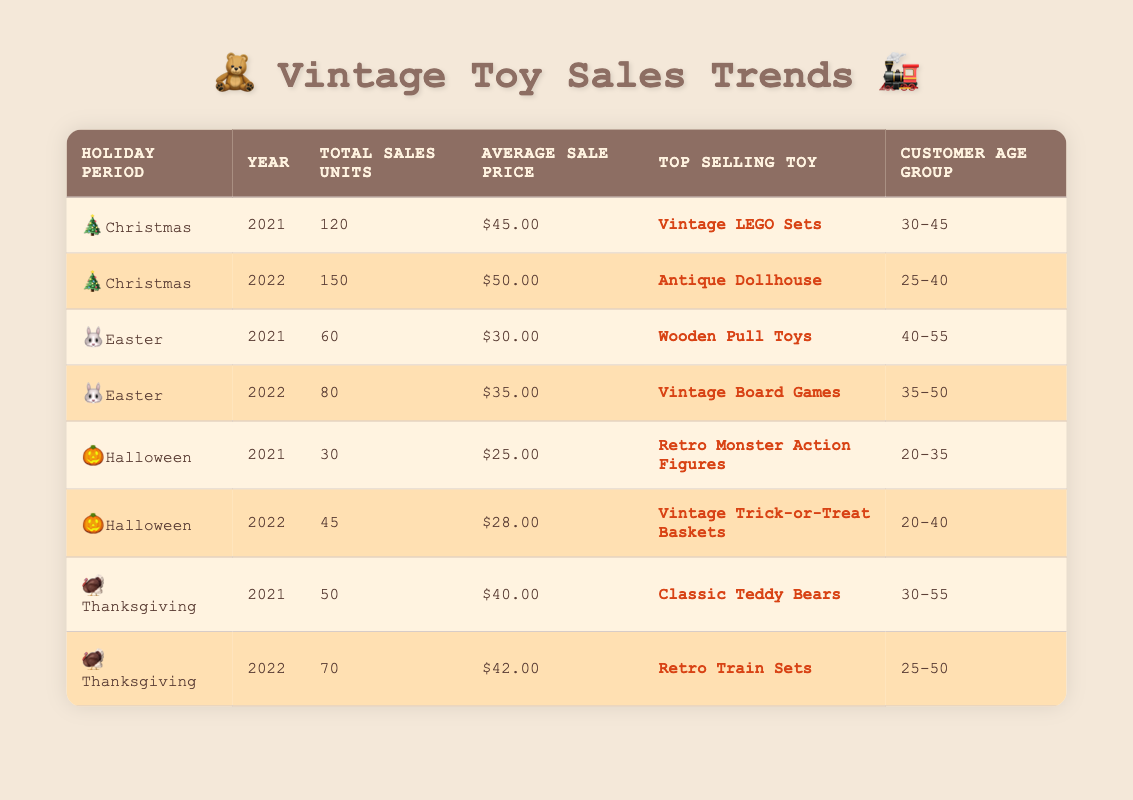What was the total sales units for Christmas in 2022? The table shows that for the holiday period of Christmas in 2022, the total sales units are listed as 150.
Answer: 150 What is the average sale price of toys during Easter in 2021? Referring to the table, the average sale price for Easter in 2021 is shown as $30.00.
Answer: $30.00 Which age group purchased the most toys during Halloween in 2022? The table indicates that for Halloween in 2022, the customer age group is listed as 20-40.
Answer: 20-40 How many more total sales units were recorded for Thanksgiving in 2022 compared to 2021? By looking at the data, Thanksgiving in 2021 recorded 50 units sold, while in 2022 it was 70 units. The difference is calculated as 70 - 50 = 20.
Answer: 20 Did the average sale price of toys increase or decrease from Thanksgiving 2021 to Thanksgiving 2022? The average sale price for Thanksgiving in 2021 was $40.00, and in 2022 it rose to $42.00, showing an increase.
Answer: Yes, it increased What was the top-selling toy during the Christmas period in 2021? According to the table, the top-selling toy during Christmas in 2021 is listed as Vintage LEGO Sets.
Answer: Vintage LEGO Sets What was the total sales units across all holiday periods in 2022? The total sales units for each holiday period in 2022 can be summed up: Christmas (150) + Easter (80) + Halloween (45) + Thanksgiving (70) = 345.
Answer: 345 Was the average sale price for vintage toys higher during Christmas in 2022 compared to Halloween in the same year? The average sale price for Christmas in 2022 is $50.00 and for Halloween in 2022 it is $28.00. Since $50.00 is greater than $28.00, the price during Christmas is higher.
Answer: Yes, it was higher Which age group primarily purchased toys for Easter in 2022? The table indicates that the customer age group for Easter in 2022 was between 35-50.
Answer: 35-50 